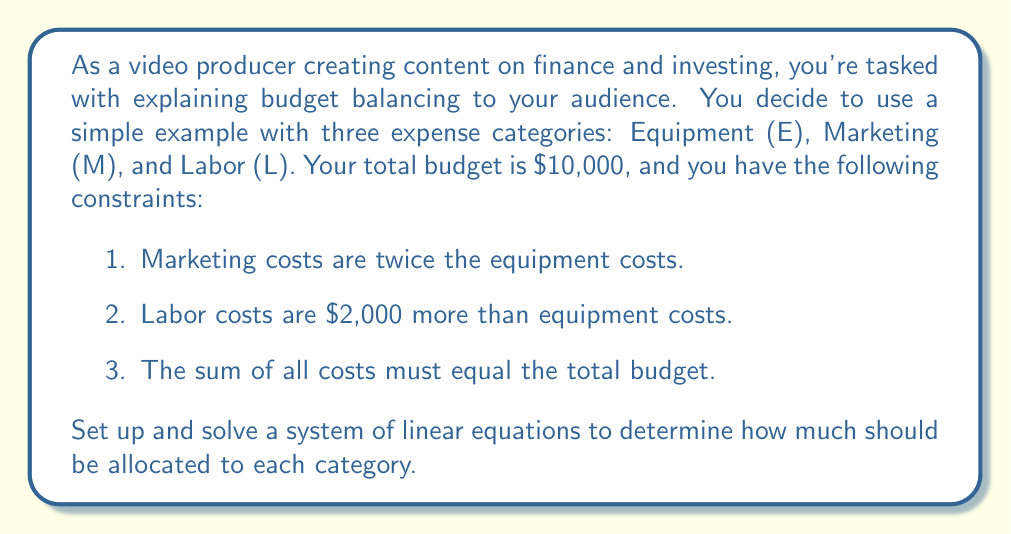Teach me how to tackle this problem. Let's approach this step-by-step:

1) First, let's define our variables:
   $E$ = Equipment costs
   $M$ = Marketing costs
   $L$ = Labor costs

2) Now, we can set up our system of equations based on the given constraints:

   Equation 1: $M = 2E$ (Marketing costs are twice the equipment costs)
   Equation 2: $L = E + 2000$ (Labor costs are $2,000 more than equipment costs)
   Equation 3: $E + M + L = 10000$ (The sum of all costs must equal the total budget)

3) We can substitute the expressions for $M$ and $L$ from equations 1 and 2 into equation 3:

   $E + 2E + (E + 2000) = 10000$

4) Simplify:

   $4E + 2000 = 10000$

5) Subtract 2000 from both sides:

   $4E = 8000$

6) Divide both sides by 4:

   $E = 2000$

7) Now that we know $E$, we can find $M$ and $L$:

   $M = 2E = 2(2000) = 4000$
   $L = E + 2000 = 2000 + 2000 = 4000$

8) Let's verify that these values satisfy our original constraints:
   - Marketing ($4000) is twice Equipment ($2000)
   - Labor ($4000) is $2000 more than Equipment ($2000)
   - The sum of all costs ($2000 + $4000 + $4000 = $10000) equals the total budget

Therefore, our solution satisfies all constraints.
Answer: Equipment (E): $2000
Marketing (M): $4000
Labor (L): $4000 